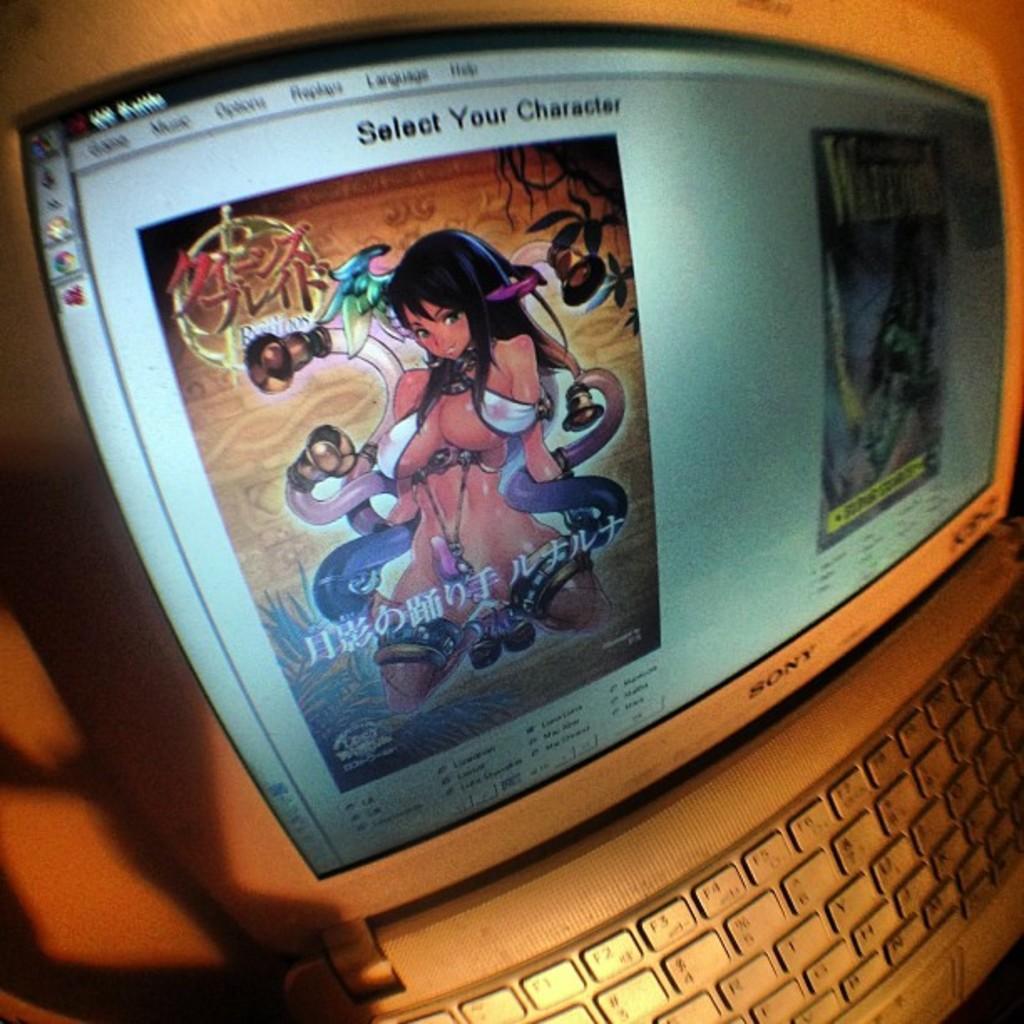Can you describe this image briefly? In the center of this picture there is an object which seems to be the laptop and we can see the text and the pictures of persons and some other objects on the display of the laptop. 